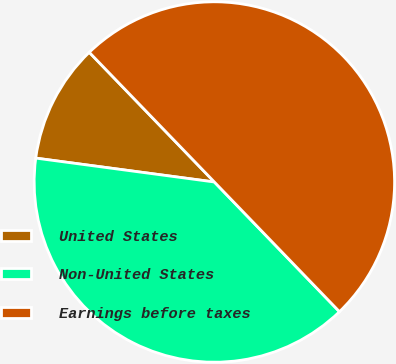Convert chart to OTSL. <chart><loc_0><loc_0><loc_500><loc_500><pie_chart><fcel>United States<fcel>Non-United States<fcel>Earnings before taxes<nl><fcel>10.67%<fcel>39.33%<fcel>50.0%<nl></chart> 